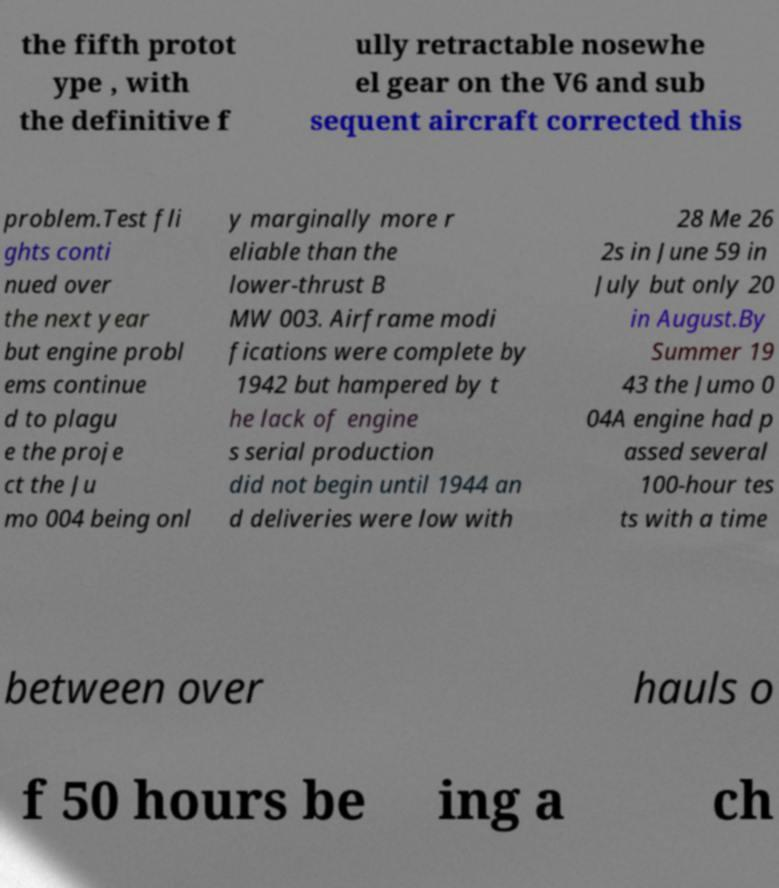There's text embedded in this image that I need extracted. Can you transcribe it verbatim? the fifth protot ype , with the definitive f ully retractable nosewhe el gear on the V6 and sub sequent aircraft corrected this problem.Test fli ghts conti nued over the next year but engine probl ems continue d to plagu e the proje ct the Ju mo 004 being onl y marginally more r eliable than the lower-thrust B MW 003. Airframe modi fications were complete by 1942 but hampered by t he lack of engine s serial production did not begin until 1944 an d deliveries were low with 28 Me 26 2s in June 59 in July but only 20 in August.By Summer 19 43 the Jumo 0 04A engine had p assed several 100-hour tes ts with a time between over hauls o f 50 hours be ing a ch 